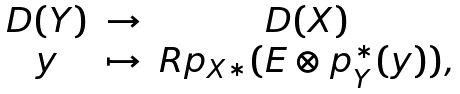<formula> <loc_0><loc_0><loc_500><loc_500>\begin{matrix} { D } ( Y ) & \to & { D } ( X ) \\ y & \mapsto & { R } p _ { X * } ( { E } \otimes p _ { Y } ^ { * } ( y ) ) , \end{matrix}</formula> 